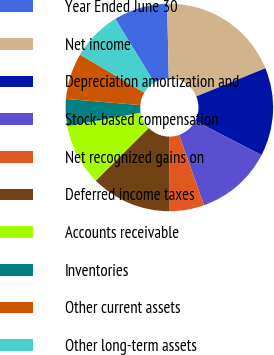Convert chart to OTSL. <chart><loc_0><loc_0><loc_500><loc_500><pie_chart><fcel>Year Ended June 30<fcel>Net income<fcel>Depreciation amortization and<fcel>Stock-based compensation<fcel>Net recognized gains on<fcel>Deferred income taxes<fcel>Accounts receivable<fcel>Inventories<fcel>Other current assets<fcel>Other long-term assets<nl><fcel>8.38%<fcel>19.16%<fcel>13.77%<fcel>11.98%<fcel>5.39%<fcel>12.57%<fcel>9.58%<fcel>4.19%<fcel>7.19%<fcel>7.78%<nl></chart> 